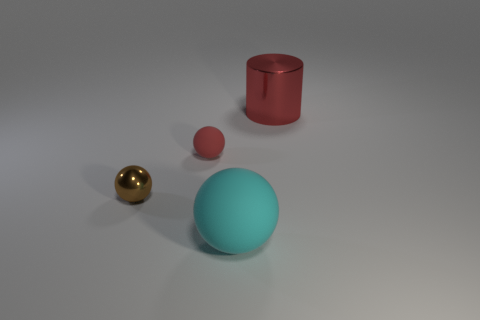Add 1 small metal objects. How many objects exist? 5 Subtract all cylinders. How many objects are left? 3 Subtract 0 purple cylinders. How many objects are left? 4 Subtract all red matte things. Subtract all tiny red rubber objects. How many objects are left? 2 Add 2 red rubber objects. How many red rubber objects are left? 3 Add 2 big yellow objects. How many big yellow objects exist? 2 